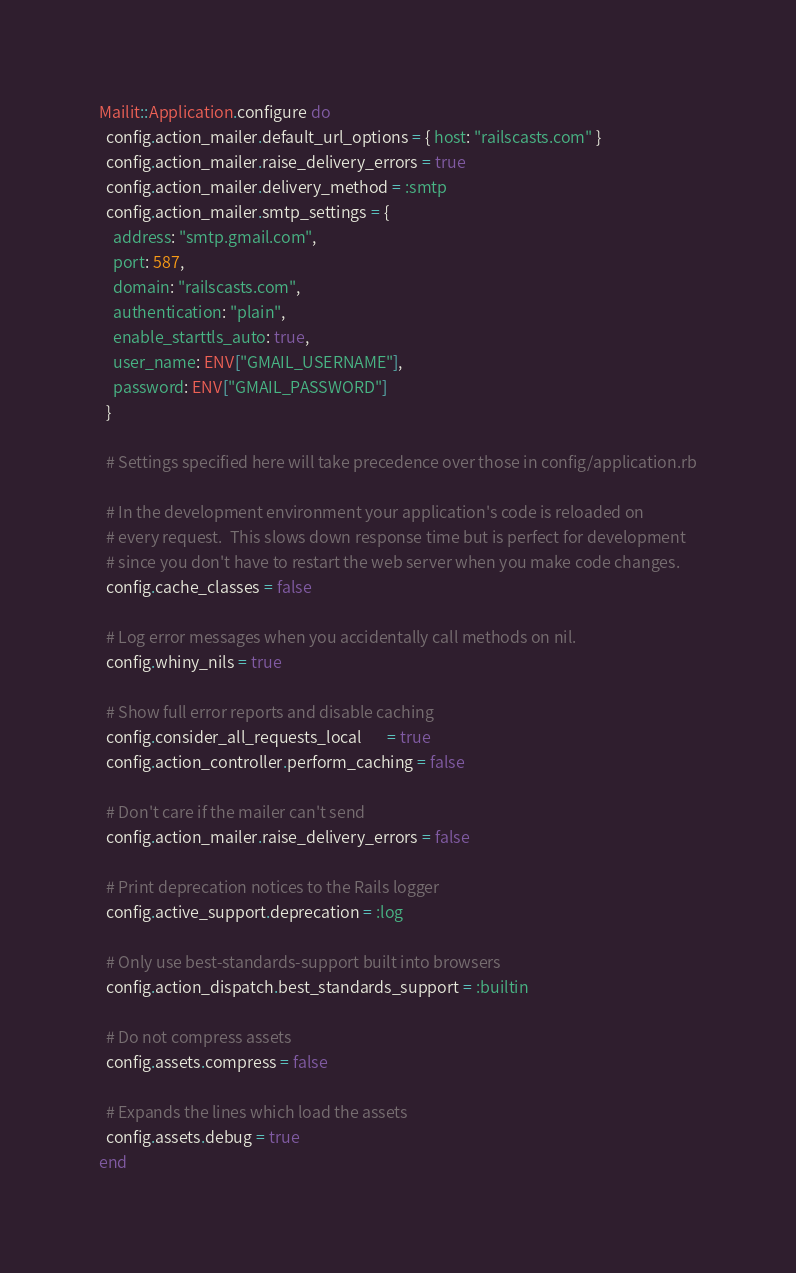<code> <loc_0><loc_0><loc_500><loc_500><_Ruby_>Mailit::Application.configure do
  config.action_mailer.default_url_options = { host: "railscasts.com" }
  config.action_mailer.raise_delivery_errors = true
  config.action_mailer.delivery_method = :smtp
  config.action_mailer.smtp_settings = {
    address: "smtp.gmail.com",
    port: 587,
    domain: "railscasts.com",
    authentication: "plain",
    enable_starttls_auto: true,
    user_name: ENV["GMAIL_USERNAME"],
    password: ENV["GMAIL_PASSWORD"]
  }

  # Settings specified here will take precedence over those in config/application.rb

  # In the development environment your application's code is reloaded on
  # every request.  This slows down response time but is perfect for development
  # since you don't have to restart the web server when you make code changes.
  config.cache_classes = false

  # Log error messages when you accidentally call methods on nil.
  config.whiny_nils = true

  # Show full error reports and disable caching
  config.consider_all_requests_local       = true
  config.action_controller.perform_caching = false

  # Don't care if the mailer can't send
  config.action_mailer.raise_delivery_errors = false

  # Print deprecation notices to the Rails logger
  config.active_support.deprecation = :log

  # Only use best-standards-support built into browsers
  config.action_dispatch.best_standards_support = :builtin

  # Do not compress assets
  config.assets.compress = false

  # Expands the lines which load the assets
  config.assets.debug = true
end
</code> 